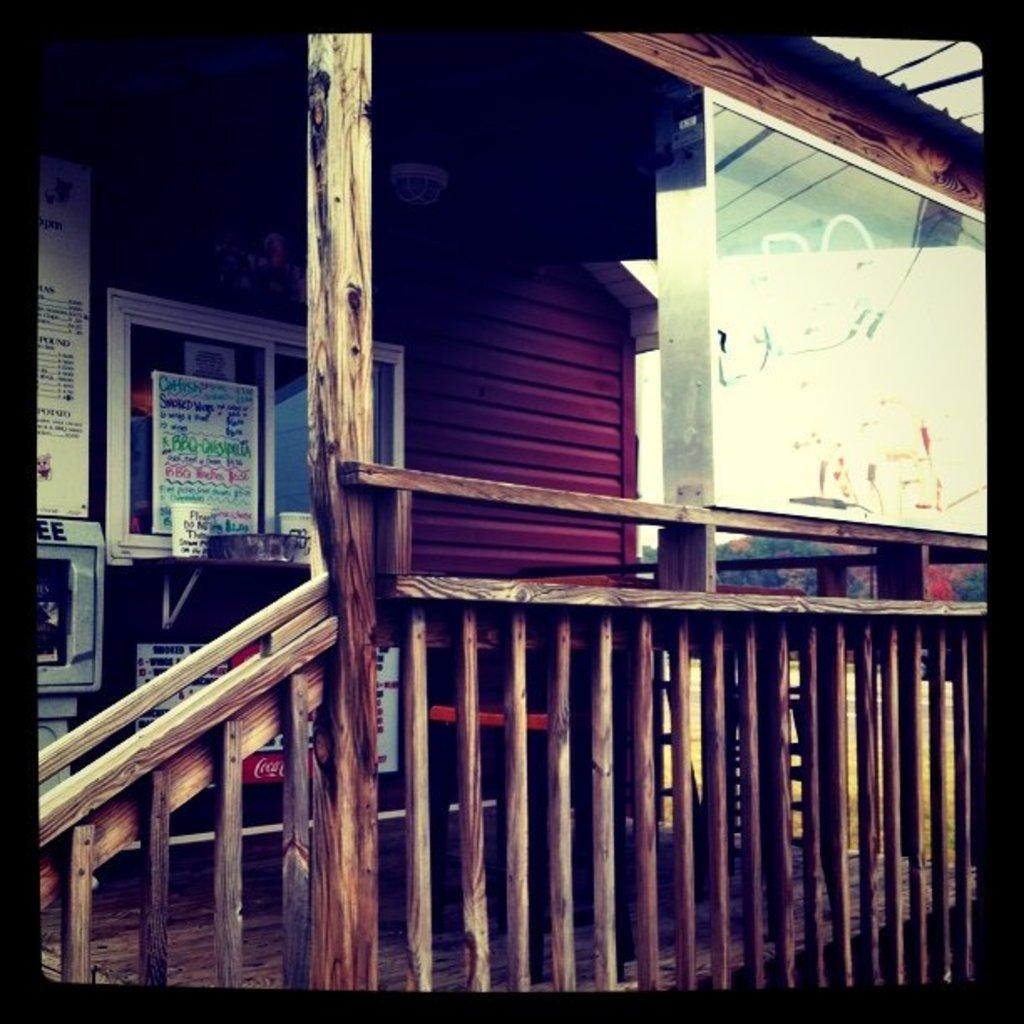What type of structure can be seen in the image? There is railing and posts in the image, which suggests a fence or barrier. What architectural feature is present in the image? There is a window in the image. What type of wall is visible in the image? There is a wall in the image. What is used to cover the window in the image? There is a screen in the image, which is likely used to cover the window. What source of light is visible in the image? There is a light in the image. What type of polish is applied to the railing in the image? There is no mention of any polish being applied to the railing in the image. What is the limit of the posts in the image? The image does not provide any information about the limit or extent of the posts. 